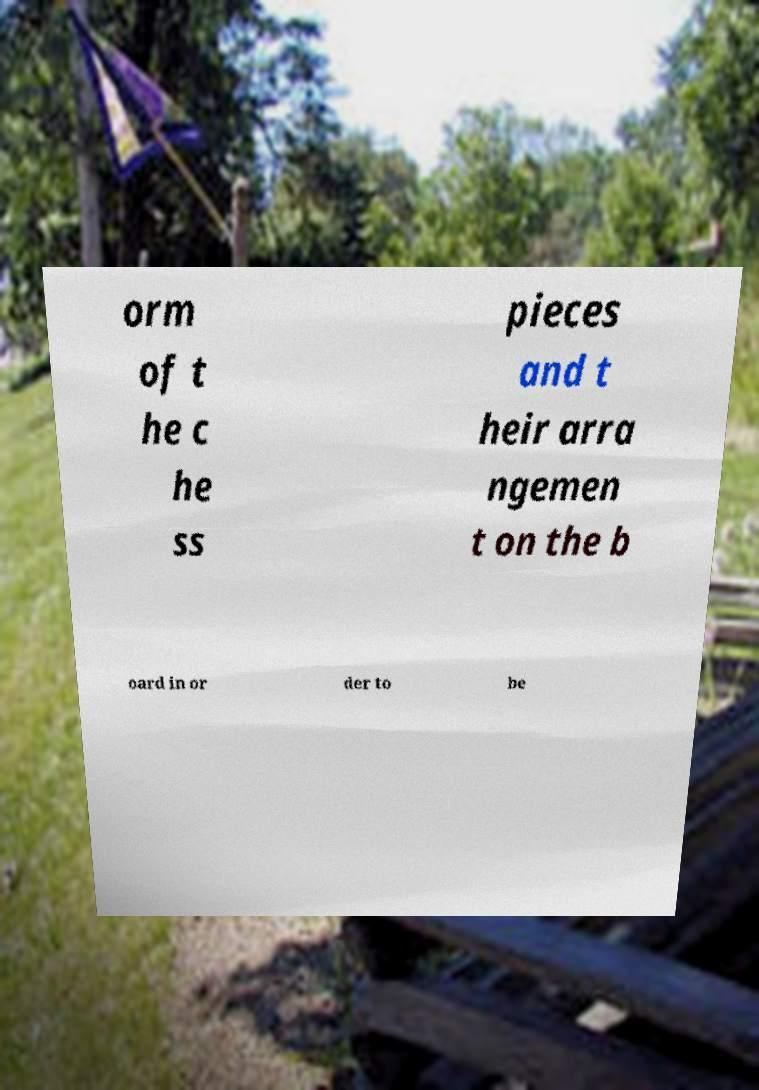Could you assist in decoding the text presented in this image and type it out clearly? orm of t he c he ss pieces and t heir arra ngemen t on the b oard in or der to be 